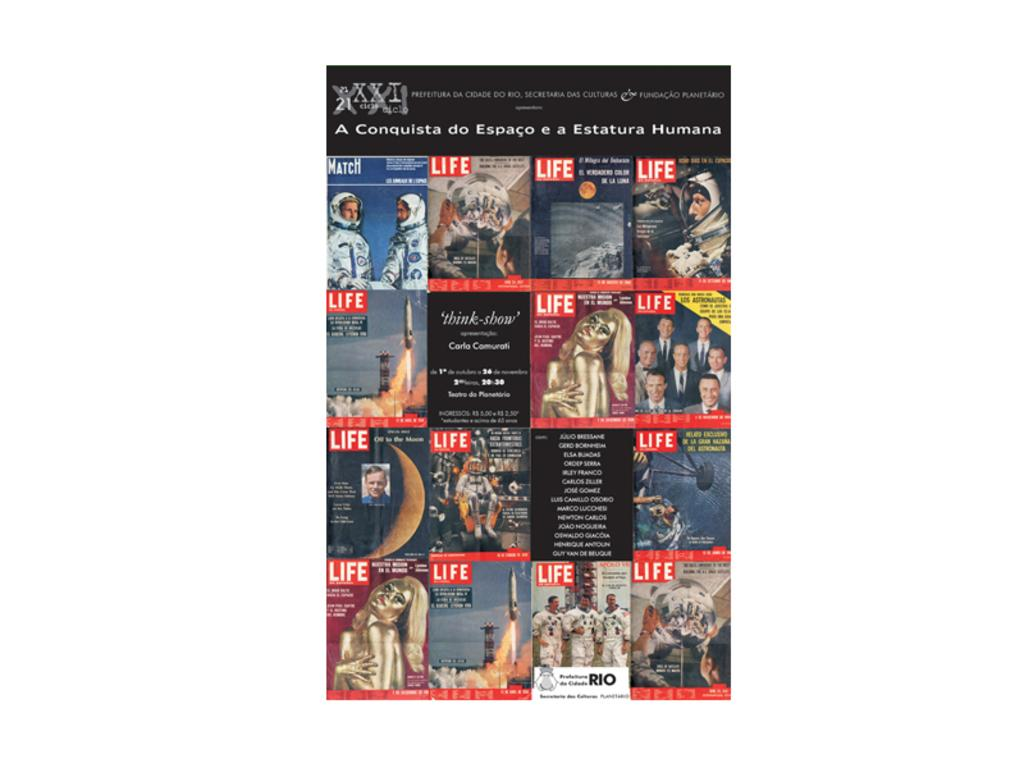<image>
Render a clear and concise summary of the photo. An assortment of various Life magazine covers over the years. 